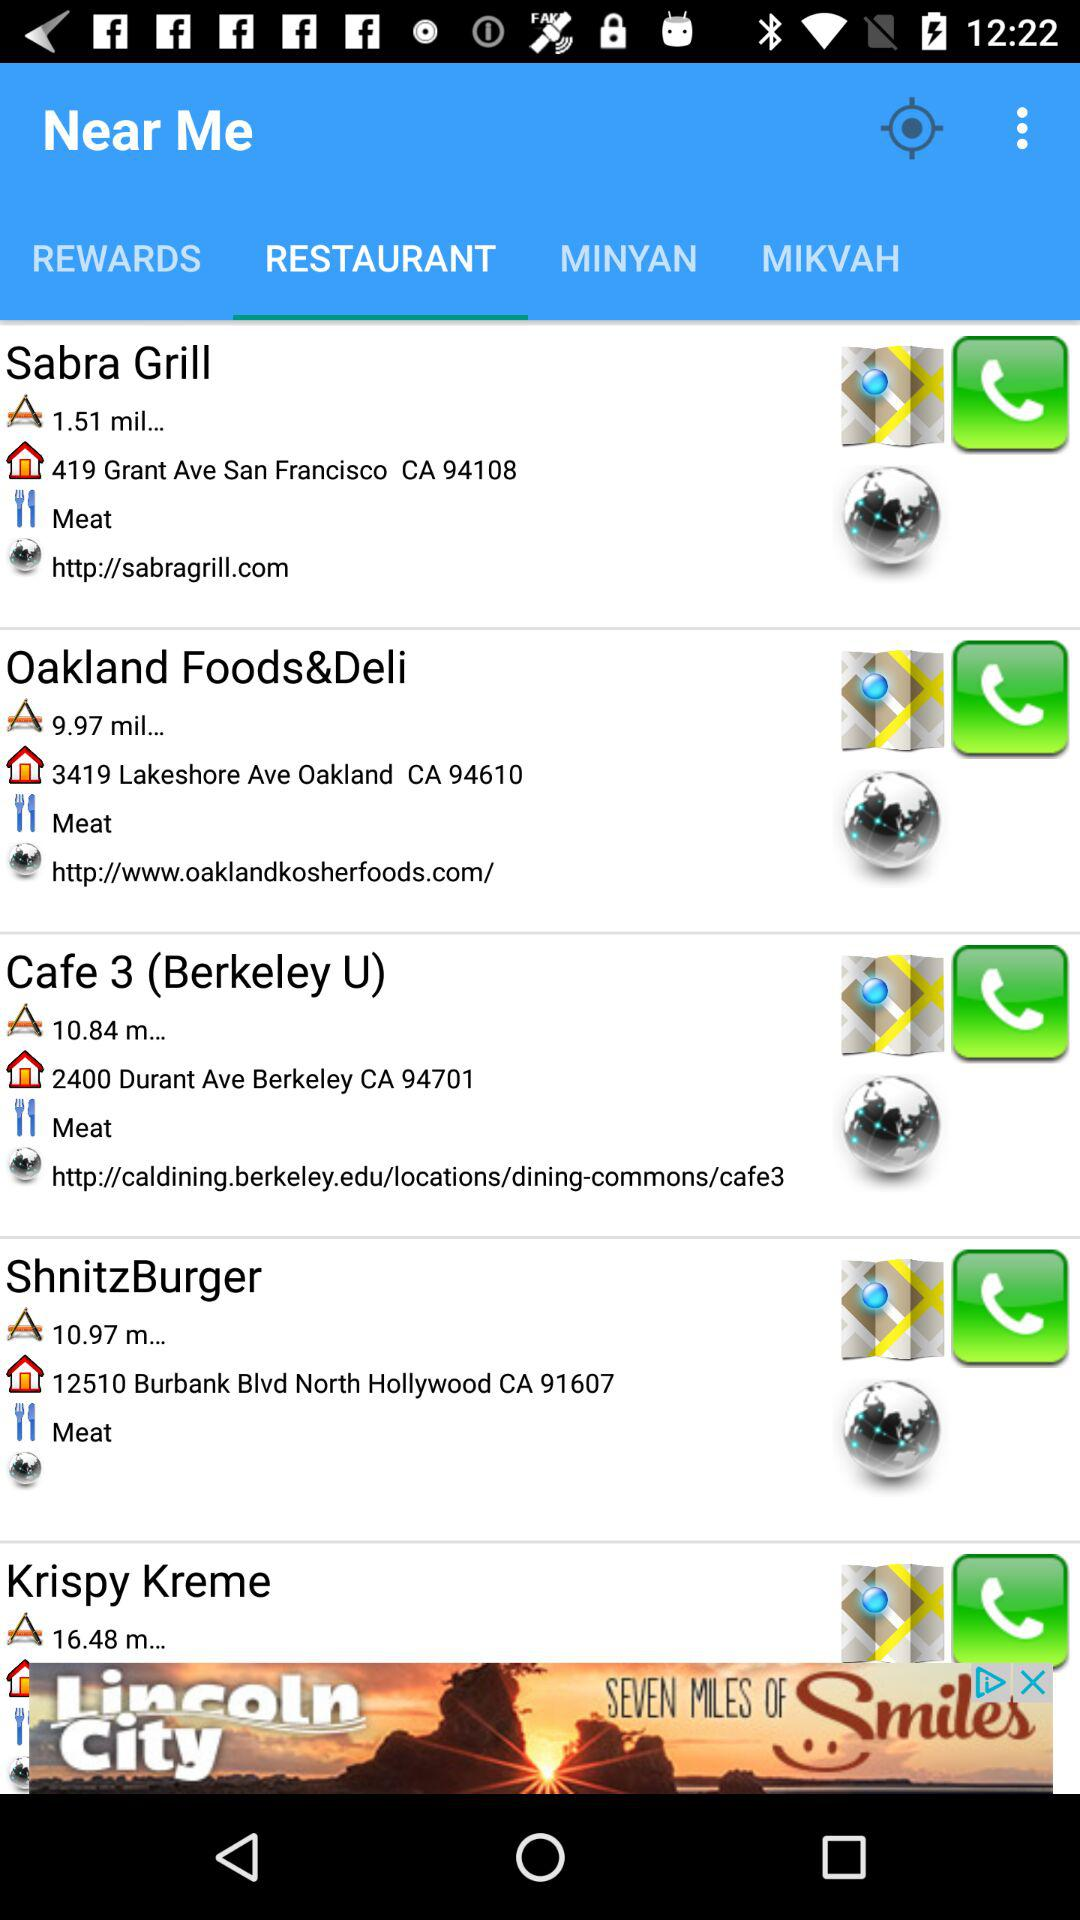What is the selected tab? The selected tab is "RESTAURANT". 